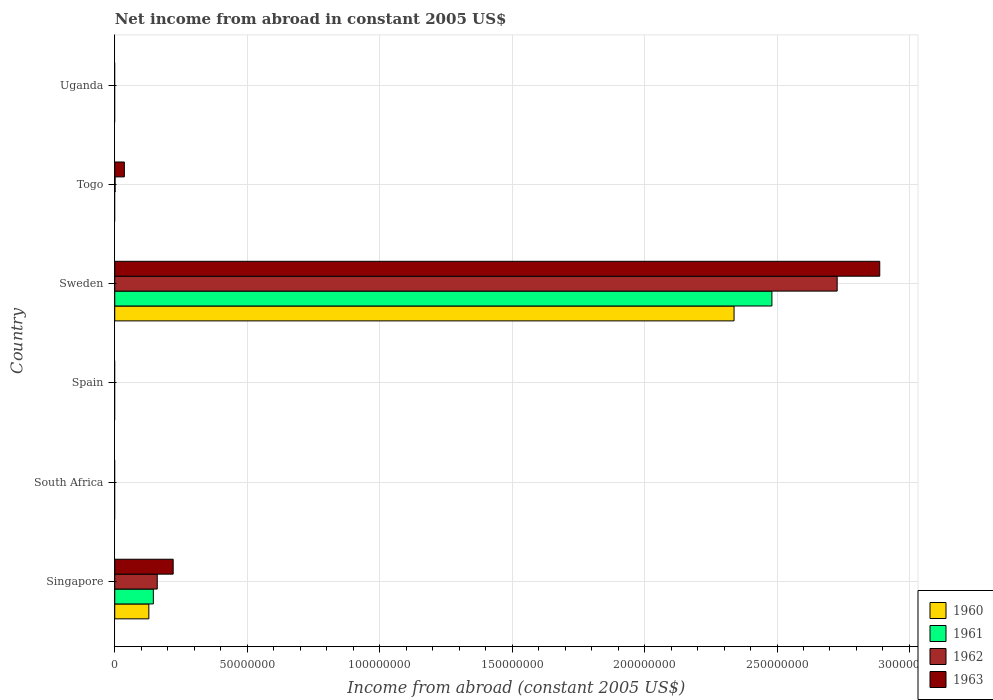Are the number of bars per tick equal to the number of legend labels?
Your answer should be very brief. No. What is the label of the 2nd group of bars from the top?
Ensure brevity in your answer.  Togo. In how many cases, is the number of bars for a given country not equal to the number of legend labels?
Provide a short and direct response. 4. What is the net income from abroad in 1962 in Singapore?
Keep it short and to the point. 1.60e+07. Across all countries, what is the maximum net income from abroad in 1961?
Offer a very short reply. 2.48e+08. Across all countries, what is the minimum net income from abroad in 1961?
Provide a succinct answer. 0. In which country was the net income from abroad in 1963 maximum?
Ensure brevity in your answer.  Sweden. What is the total net income from abroad in 1963 in the graph?
Offer a very short reply. 3.14e+08. What is the difference between the net income from abroad in 1963 in Singapore and that in Sweden?
Offer a terse response. -2.67e+08. What is the difference between the net income from abroad in 1961 in Uganda and the net income from abroad in 1960 in Spain?
Offer a terse response. 0. What is the average net income from abroad in 1963 per country?
Provide a short and direct response. 5.24e+07. What is the difference between the net income from abroad in 1960 and net income from abroad in 1963 in Sweden?
Keep it short and to the point. -5.50e+07. In how many countries, is the net income from abroad in 1962 greater than 210000000 US$?
Your answer should be very brief. 1. What is the difference between the highest and the second highest net income from abroad in 1962?
Provide a short and direct response. 2.57e+08. What is the difference between the highest and the lowest net income from abroad in 1963?
Keep it short and to the point. 2.89e+08. In how many countries, is the net income from abroad in 1963 greater than the average net income from abroad in 1963 taken over all countries?
Give a very brief answer. 1. Is it the case that in every country, the sum of the net income from abroad in 1962 and net income from abroad in 1961 is greater than the sum of net income from abroad in 1963 and net income from abroad in 1960?
Your answer should be very brief. No. Are all the bars in the graph horizontal?
Provide a short and direct response. Yes. How many countries are there in the graph?
Make the answer very short. 6. Are the values on the major ticks of X-axis written in scientific E-notation?
Offer a terse response. No. Does the graph contain any zero values?
Your answer should be very brief. Yes. Does the graph contain grids?
Provide a short and direct response. Yes. Where does the legend appear in the graph?
Your response must be concise. Bottom right. How many legend labels are there?
Ensure brevity in your answer.  4. What is the title of the graph?
Provide a short and direct response. Net income from abroad in constant 2005 US$. What is the label or title of the X-axis?
Your response must be concise. Income from abroad (constant 2005 US$). What is the Income from abroad (constant 2005 US$) of 1960 in Singapore?
Give a very brief answer. 1.29e+07. What is the Income from abroad (constant 2005 US$) of 1961 in Singapore?
Your answer should be compact. 1.46e+07. What is the Income from abroad (constant 2005 US$) in 1962 in Singapore?
Your response must be concise. 1.60e+07. What is the Income from abroad (constant 2005 US$) of 1963 in Singapore?
Provide a succinct answer. 2.20e+07. What is the Income from abroad (constant 2005 US$) of 1960 in South Africa?
Ensure brevity in your answer.  0. What is the Income from abroad (constant 2005 US$) in 1962 in South Africa?
Make the answer very short. 0. What is the Income from abroad (constant 2005 US$) in 1961 in Spain?
Provide a short and direct response. 0. What is the Income from abroad (constant 2005 US$) in 1963 in Spain?
Offer a terse response. 0. What is the Income from abroad (constant 2005 US$) of 1960 in Sweden?
Your answer should be compact. 2.34e+08. What is the Income from abroad (constant 2005 US$) in 1961 in Sweden?
Make the answer very short. 2.48e+08. What is the Income from abroad (constant 2005 US$) in 1962 in Sweden?
Keep it short and to the point. 2.73e+08. What is the Income from abroad (constant 2005 US$) of 1963 in Sweden?
Offer a very short reply. 2.89e+08. What is the Income from abroad (constant 2005 US$) in 1960 in Togo?
Ensure brevity in your answer.  0. What is the Income from abroad (constant 2005 US$) of 1961 in Togo?
Make the answer very short. 0. What is the Income from abroad (constant 2005 US$) in 1962 in Togo?
Ensure brevity in your answer.  1.22e+05. What is the Income from abroad (constant 2005 US$) in 1963 in Togo?
Ensure brevity in your answer.  3.62e+06. Across all countries, what is the maximum Income from abroad (constant 2005 US$) in 1960?
Offer a terse response. 2.34e+08. Across all countries, what is the maximum Income from abroad (constant 2005 US$) of 1961?
Give a very brief answer. 2.48e+08. Across all countries, what is the maximum Income from abroad (constant 2005 US$) in 1962?
Your answer should be compact. 2.73e+08. Across all countries, what is the maximum Income from abroad (constant 2005 US$) of 1963?
Provide a short and direct response. 2.89e+08. Across all countries, what is the minimum Income from abroad (constant 2005 US$) of 1960?
Your answer should be compact. 0. Across all countries, what is the minimum Income from abroad (constant 2005 US$) of 1961?
Make the answer very short. 0. Across all countries, what is the minimum Income from abroad (constant 2005 US$) of 1963?
Make the answer very short. 0. What is the total Income from abroad (constant 2005 US$) of 1960 in the graph?
Give a very brief answer. 2.47e+08. What is the total Income from abroad (constant 2005 US$) of 1961 in the graph?
Your response must be concise. 2.63e+08. What is the total Income from abroad (constant 2005 US$) in 1962 in the graph?
Provide a succinct answer. 2.89e+08. What is the total Income from abroad (constant 2005 US$) of 1963 in the graph?
Offer a very short reply. 3.14e+08. What is the difference between the Income from abroad (constant 2005 US$) in 1960 in Singapore and that in Sweden?
Offer a very short reply. -2.21e+08. What is the difference between the Income from abroad (constant 2005 US$) in 1961 in Singapore and that in Sweden?
Give a very brief answer. -2.34e+08. What is the difference between the Income from abroad (constant 2005 US$) of 1962 in Singapore and that in Sweden?
Make the answer very short. -2.57e+08. What is the difference between the Income from abroad (constant 2005 US$) in 1963 in Singapore and that in Sweden?
Ensure brevity in your answer.  -2.67e+08. What is the difference between the Income from abroad (constant 2005 US$) of 1962 in Singapore and that in Togo?
Make the answer very short. 1.59e+07. What is the difference between the Income from abroad (constant 2005 US$) in 1963 in Singapore and that in Togo?
Offer a terse response. 1.84e+07. What is the difference between the Income from abroad (constant 2005 US$) of 1962 in Sweden and that in Togo?
Keep it short and to the point. 2.73e+08. What is the difference between the Income from abroad (constant 2005 US$) in 1963 in Sweden and that in Togo?
Make the answer very short. 2.85e+08. What is the difference between the Income from abroad (constant 2005 US$) in 1960 in Singapore and the Income from abroad (constant 2005 US$) in 1961 in Sweden?
Make the answer very short. -2.35e+08. What is the difference between the Income from abroad (constant 2005 US$) in 1960 in Singapore and the Income from abroad (constant 2005 US$) in 1962 in Sweden?
Your answer should be very brief. -2.60e+08. What is the difference between the Income from abroad (constant 2005 US$) of 1960 in Singapore and the Income from abroad (constant 2005 US$) of 1963 in Sweden?
Your answer should be very brief. -2.76e+08. What is the difference between the Income from abroad (constant 2005 US$) in 1961 in Singapore and the Income from abroad (constant 2005 US$) in 1962 in Sweden?
Provide a short and direct response. -2.58e+08. What is the difference between the Income from abroad (constant 2005 US$) in 1961 in Singapore and the Income from abroad (constant 2005 US$) in 1963 in Sweden?
Provide a succinct answer. -2.74e+08. What is the difference between the Income from abroad (constant 2005 US$) of 1962 in Singapore and the Income from abroad (constant 2005 US$) of 1963 in Sweden?
Keep it short and to the point. -2.73e+08. What is the difference between the Income from abroad (constant 2005 US$) of 1960 in Singapore and the Income from abroad (constant 2005 US$) of 1962 in Togo?
Provide a succinct answer. 1.27e+07. What is the difference between the Income from abroad (constant 2005 US$) in 1960 in Singapore and the Income from abroad (constant 2005 US$) in 1963 in Togo?
Your response must be concise. 9.25e+06. What is the difference between the Income from abroad (constant 2005 US$) of 1961 in Singapore and the Income from abroad (constant 2005 US$) of 1962 in Togo?
Offer a very short reply. 1.44e+07. What is the difference between the Income from abroad (constant 2005 US$) in 1961 in Singapore and the Income from abroad (constant 2005 US$) in 1963 in Togo?
Provide a short and direct response. 1.09e+07. What is the difference between the Income from abroad (constant 2005 US$) of 1962 in Singapore and the Income from abroad (constant 2005 US$) of 1963 in Togo?
Provide a succinct answer. 1.24e+07. What is the difference between the Income from abroad (constant 2005 US$) of 1960 in Sweden and the Income from abroad (constant 2005 US$) of 1962 in Togo?
Your response must be concise. 2.34e+08. What is the difference between the Income from abroad (constant 2005 US$) of 1960 in Sweden and the Income from abroad (constant 2005 US$) of 1963 in Togo?
Keep it short and to the point. 2.30e+08. What is the difference between the Income from abroad (constant 2005 US$) of 1961 in Sweden and the Income from abroad (constant 2005 US$) of 1962 in Togo?
Ensure brevity in your answer.  2.48e+08. What is the difference between the Income from abroad (constant 2005 US$) of 1961 in Sweden and the Income from abroad (constant 2005 US$) of 1963 in Togo?
Your answer should be compact. 2.44e+08. What is the difference between the Income from abroad (constant 2005 US$) of 1962 in Sweden and the Income from abroad (constant 2005 US$) of 1963 in Togo?
Ensure brevity in your answer.  2.69e+08. What is the average Income from abroad (constant 2005 US$) of 1960 per country?
Give a very brief answer. 4.11e+07. What is the average Income from abroad (constant 2005 US$) of 1961 per country?
Offer a very short reply. 4.38e+07. What is the average Income from abroad (constant 2005 US$) in 1962 per country?
Make the answer very short. 4.81e+07. What is the average Income from abroad (constant 2005 US$) in 1963 per country?
Provide a short and direct response. 5.24e+07. What is the difference between the Income from abroad (constant 2005 US$) in 1960 and Income from abroad (constant 2005 US$) in 1961 in Singapore?
Your answer should be very brief. -1.70e+06. What is the difference between the Income from abroad (constant 2005 US$) of 1960 and Income from abroad (constant 2005 US$) of 1962 in Singapore?
Provide a short and direct response. -3.17e+06. What is the difference between the Income from abroad (constant 2005 US$) of 1960 and Income from abroad (constant 2005 US$) of 1963 in Singapore?
Keep it short and to the point. -9.18e+06. What is the difference between the Income from abroad (constant 2005 US$) of 1961 and Income from abroad (constant 2005 US$) of 1962 in Singapore?
Your answer should be very brief. -1.47e+06. What is the difference between the Income from abroad (constant 2005 US$) of 1961 and Income from abroad (constant 2005 US$) of 1963 in Singapore?
Offer a terse response. -7.48e+06. What is the difference between the Income from abroad (constant 2005 US$) of 1962 and Income from abroad (constant 2005 US$) of 1963 in Singapore?
Offer a very short reply. -6.01e+06. What is the difference between the Income from abroad (constant 2005 US$) in 1960 and Income from abroad (constant 2005 US$) in 1961 in Sweden?
Keep it short and to the point. -1.43e+07. What is the difference between the Income from abroad (constant 2005 US$) of 1960 and Income from abroad (constant 2005 US$) of 1962 in Sweden?
Make the answer very short. -3.89e+07. What is the difference between the Income from abroad (constant 2005 US$) in 1960 and Income from abroad (constant 2005 US$) in 1963 in Sweden?
Your response must be concise. -5.50e+07. What is the difference between the Income from abroad (constant 2005 US$) of 1961 and Income from abroad (constant 2005 US$) of 1962 in Sweden?
Ensure brevity in your answer.  -2.46e+07. What is the difference between the Income from abroad (constant 2005 US$) in 1961 and Income from abroad (constant 2005 US$) in 1963 in Sweden?
Provide a succinct answer. -4.07e+07. What is the difference between the Income from abroad (constant 2005 US$) of 1962 and Income from abroad (constant 2005 US$) of 1963 in Sweden?
Offer a terse response. -1.61e+07. What is the difference between the Income from abroad (constant 2005 US$) of 1962 and Income from abroad (constant 2005 US$) of 1963 in Togo?
Offer a very short reply. -3.50e+06. What is the ratio of the Income from abroad (constant 2005 US$) in 1960 in Singapore to that in Sweden?
Keep it short and to the point. 0.06. What is the ratio of the Income from abroad (constant 2005 US$) of 1961 in Singapore to that in Sweden?
Your answer should be compact. 0.06. What is the ratio of the Income from abroad (constant 2005 US$) in 1962 in Singapore to that in Sweden?
Keep it short and to the point. 0.06. What is the ratio of the Income from abroad (constant 2005 US$) in 1963 in Singapore to that in Sweden?
Keep it short and to the point. 0.08. What is the ratio of the Income from abroad (constant 2005 US$) of 1962 in Singapore to that in Togo?
Your answer should be very brief. 131.21. What is the ratio of the Income from abroad (constant 2005 US$) in 1963 in Singapore to that in Togo?
Your answer should be compact. 6.08. What is the ratio of the Income from abroad (constant 2005 US$) of 1962 in Sweden to that in Togo?
Provide a succinct answer. 2230.99. What is the ratio of the Income from abroad (constant 2005 US$) of 1963 in Sweden to that in Togo?
Give a very brief answer. 79.67. What is the difference between the highest and the second highest Income from abroad (constant 2005 US$) in 1962?
Your answer should be compact. 2.57e+08. What is the difference between the highest and the second highest Income from abroad (constant 2005 US$) of 1963?
Offer a very short reply. 2.67e+08. What is the difference between the highest and the lowest Income from abroad (constant 2005 US$) of 1960?
Your answer should be compact. 2.34e+08. What is the difference between the highest and the lowest Income from abroad (constant 2005 US$) of 1961?
Your response must be concise. 2.48e+08. What is the difference between the highest and the lowest Income from abroad (constant 2005 US$) in 1962?
Your answer should be compact. 2.73e+08. What is the difference between the highest and the lowest Income from abroad (constant 2005 US$) in 1963?
Your answer should be compact. 2.89e+08. 